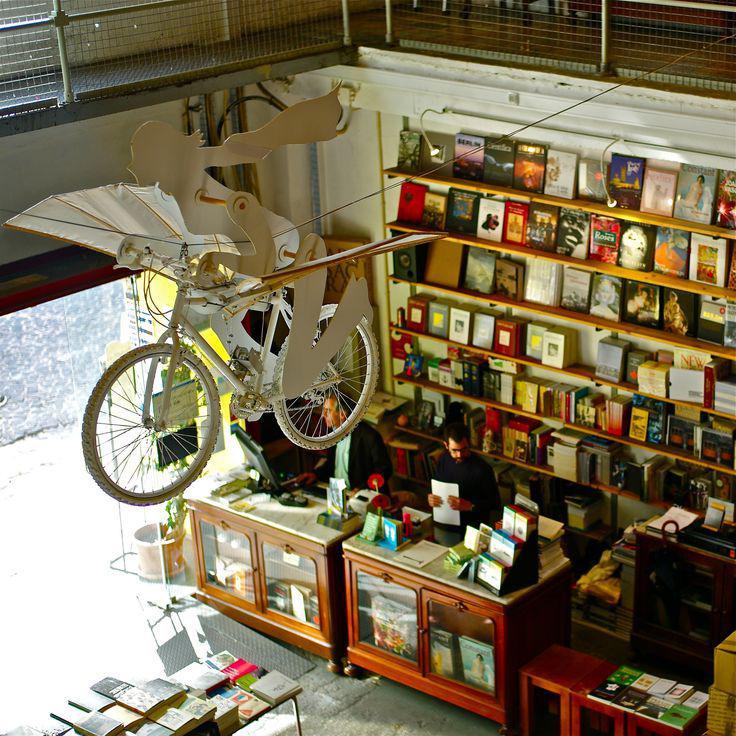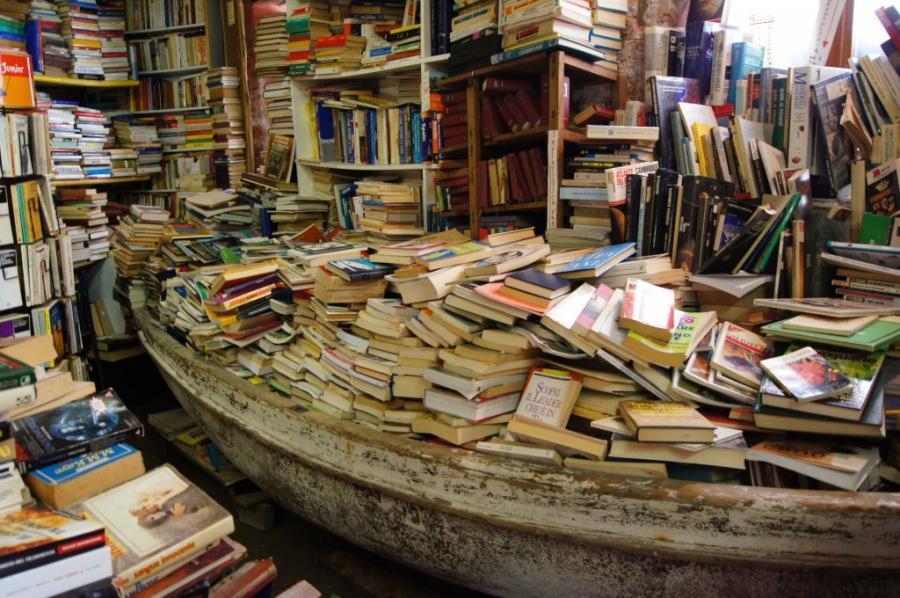The first image is the image on the left, the second image is the image on the right. Examine the images to the left and right. Is the description "One of the images includes a bicycle suspended in the air." accurate? Answer yes or no. Yes. The first image is the image on the left, the second image is the image on the right. For the images shown, is this caption "There is a bicycle hanging from the ceiling." true? Answer yes or no. Yes. 